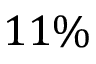Convert formula to latex. <formula><loc_0><loc_0><loc_500><loc_500>1 1 \%</formula> 